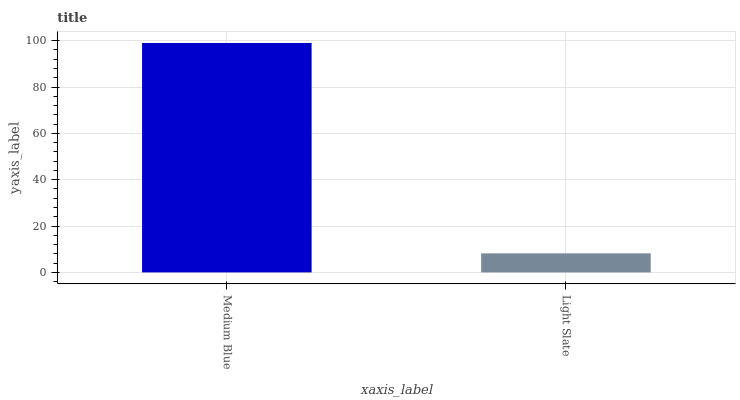Is Light Slate the minimum?
Answer yes or no. Yes. Is Medium Blue the maximum?
Answer yes or no. Yes. Is Light Slate the maximum?
Answer yes or no. No. Is Medium Blue greater than Light Slate?
Answer yes or no. Yes. Is Light Slate less than Medium Blue?
Answer yes or no. Yes. Is Light Slate greater than Medium Blue?
Answer yes or no. No. Is Medium Blue less than Light Slate?
Answer yes or no. No. Is Medium Blue the high median?
Answer yes or no. Yes. Is Light Slate the low median?
Answer yes or no. Yes. Is Light Slate the high median?
Answer yes or no. No. Is Medium Blue the low median?
Answer yes or no. No. 